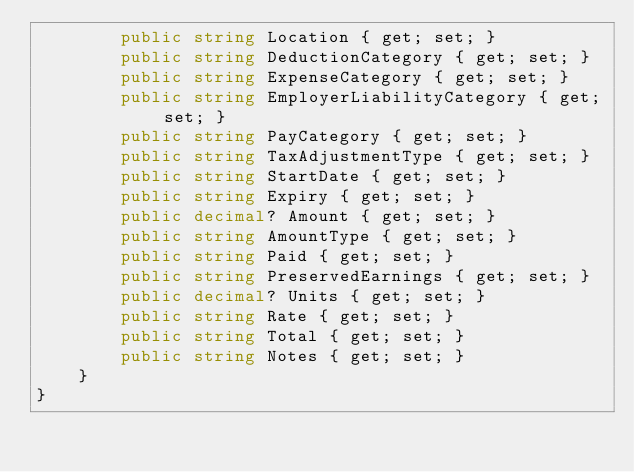Convert code to text. <code><loc_0><loc_0><loc_500><loc_500><_C#_>        public string Location { get; set; }
        public string DeductionCategory { get; set; }
        public string ExpenseCategory { get; set; }
        public string EmployerLiabilityCategory { get; set; }
        public string PayCategory { get; set; }
        public string TaxAdjustmentType { get; set; }
        public string StartDate { get; set; }
        public string Expiry { get; set; }
        public decimal? Amount { get; set; }
        public string AmountType { get; set; }
        public string Paid { get; set; }
        public string PreservedEarnings { get; set; }
        public decimal? Units { get; set; }
        public string Rate { get; set; }
        public string Total { get; set; }
        public string Notes { get; set; }
    }
}
</code> 